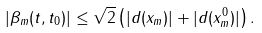Convert formula to latex. <formula><loc_0><loc_0><loc_500><loc_500>| \beta _ { m } ( t , t _ { 0 } ) | \leq \sqrt { 2 } \left ( | d ( x _ { m } ) | + | d ( x ^ { 0 } _ { m } ) | \right ) .</formula> 